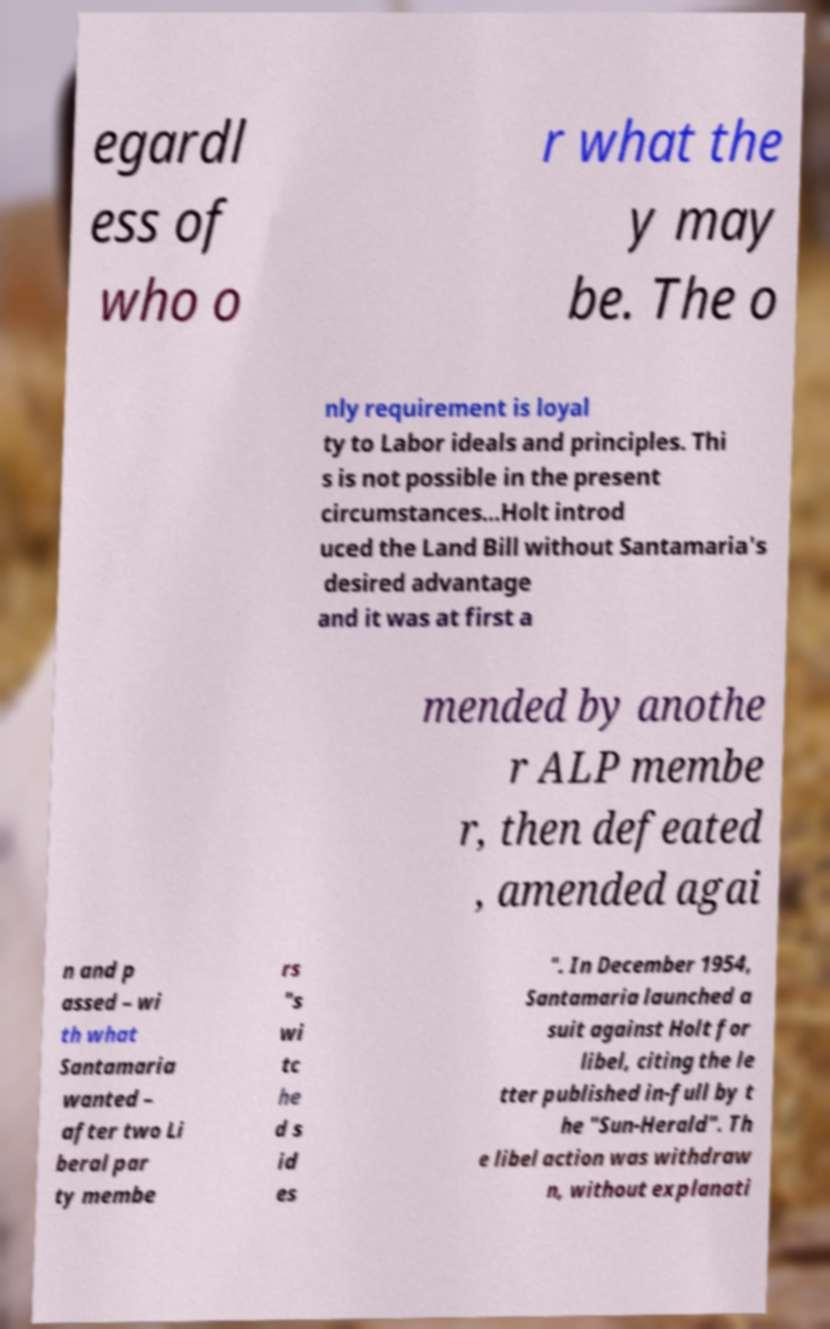Can you read and provide the text displayed in the image?This photo seems to have some interesting text. Can you extract and type it out for me? egardl ess of who o r what the y may be. The o nly requirement is loyal ty to Labor ideals and principles. Thi s is not possible in the present circumstances...Holt introd uced the Land Bill without Santamaria's desired advantage and it was at first a mended by anothe r ALP membe r, then defeated , amended agai n and p assed – wi th what Santamaria wanted – after two Li beral par ty membe rs "s wi tc he d s id es ". In December 1954, Santamaria launched a suit against Holt for libel, citing the le tter published in-full by t he "Sun-Herald". Th e libel action was withdraw n, without explanati 